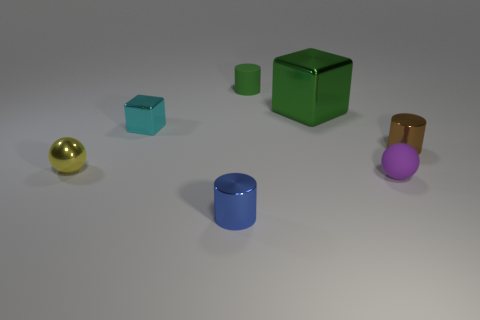What number of things are both in front of the tiny cyan cube and behind the brown metallic cylinder?
Give a very brief answer. 0. What number of other objects are there of the same material as the purple sphere?
Your response must be concise. 1. There is a tiny metal cylinder that is behind the thing left of the small cyan block; what is its color?
Offer a terse response. Brown. Does the tiny rubber thing that is in front of the tiny yellow object have the same color as the tiny metal block?
Offer a very short reply. No. Do the green cube and the blue object have the same size?
Provide a succinct answer. No. There is a blue object that is the same size as the brown cylinder; what shape is it?
Your answer should be compact. Cylinder. There is a thing in front of the purple matte object; is it the same size as the green matte object?
Keep it short and to the point. Yes. There is a brown cylinder that is the same size as the purple sphere; what material is it?
Keep it short and to the point. Metal. Are there any tiny things that are behind the small sphere that is to the right of the tiny cylinder left of the tiny green object?
Your answer should be compact. Yes. Is there anything else that has the same shape as the green rubber object?
Ensure brevity in your answer.  Yes. 